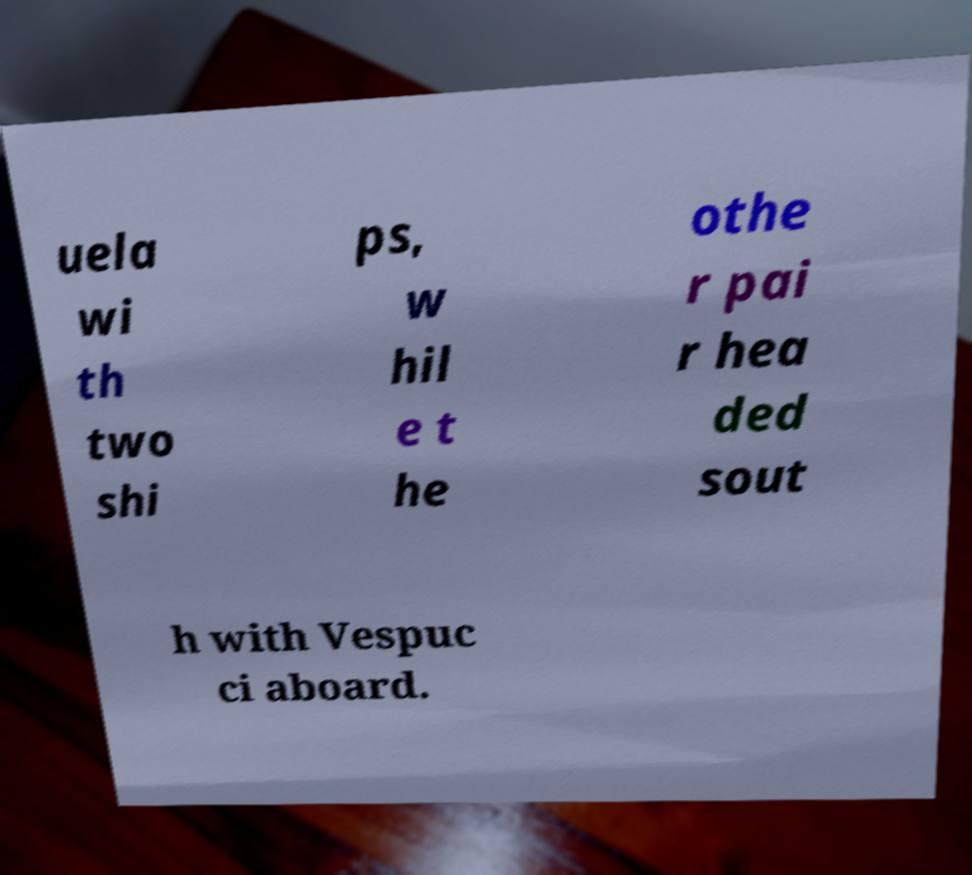I need the written content from this picture converted into text. Can you do that? uela wi th two shi ps, w hil e t he othe r pai r hea ded sout h with Vespuc ci aboard. 